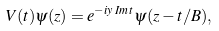<formula> <loc_0><loc_0><loc_500><loc_500>V ( t ) \psi ( z ) = e ^ { - i y \, I m \, t } \psi ( z - t / B ) ,</formula> 